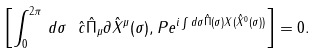Convert formula to latex. <formula><loc_0><loc_0><loc_500><loc_500>\left [ \int _ { 0 } ^ { 2 \pi } \, d \sigma \ \hat { c } \hat { \Pi } _ { \mu } \partial \hat { X } ^ { \mu } ( \sigma ) , P e ^ { i \int d \sigma \hat { \Pi } ( \sigma ) X ( \hat { X } ^ { 0 } ( \sigma ) ) } \right ] = 0 .</formula> 